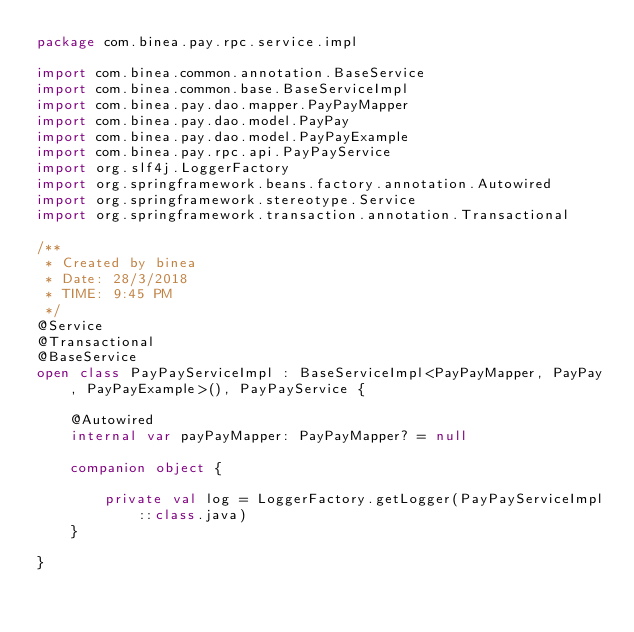Convert code to text. <code><loc_0><loc_0><loc_500><loc_500><_Kotlin_>package com.binea.pay.rpc.service.impl

import com.binea.common.annotation.BaseService
import com.binea.common.base.BaseServiceImpl
import com.binea.pay.dao.mapper.PayPayMapper
import com.binea.pay.dao.model.PayPay
import com.binea.pay.dao.model.PayPayExample
import com.binea.pay.rpc.api.PayPayService
import org.slf4j.LoggerFactory
import org.springframework.beans.factory.annotation.Autowired
import org.springframework.stereotype.Service
import org.springframework.transaction.annotation.Transactional

/**
 * Created by binea
 * Date: 28/3/2018
 * TIME: 9:45 PM
 */
@Service
@Transactional
@BaseService
open class PayPayServiceImpl : BaseServiceImpl<PayPayMapper, PayPay, PayPayExample>(), PayPayService {

    @Autowired
    internal var payPayMapper: PayPayMapper? = null

    companion object {

        private val log = LoggerFactory.getLogger(PayPayServiceImpl::class.java)
    }

}</code> 